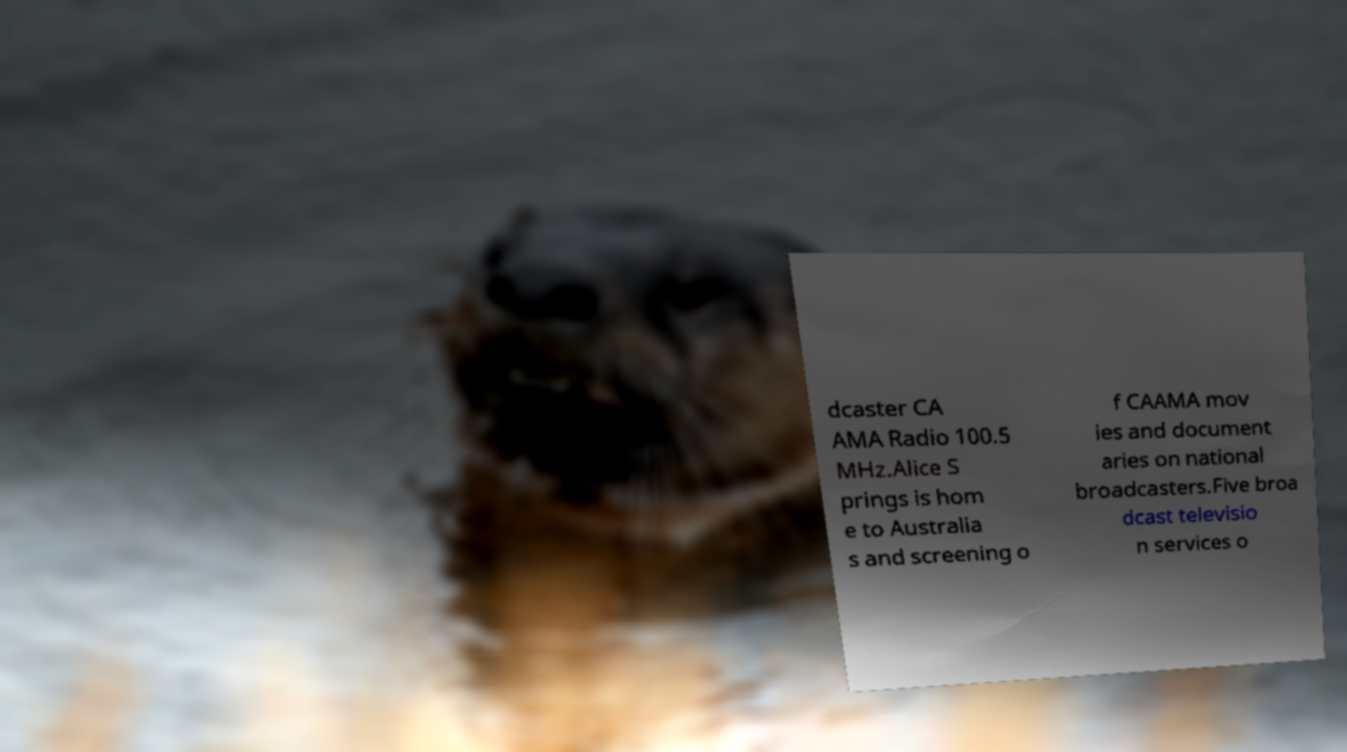Can you accurately transcribe the text from the provided image for me? dcaster CA AMA Radio 100.5 MHz.Alice S prings is hom e to Australia s and screening o f CAAMA mov ies and document aries on national broadcasters.Five broa dcast televisio n services o 